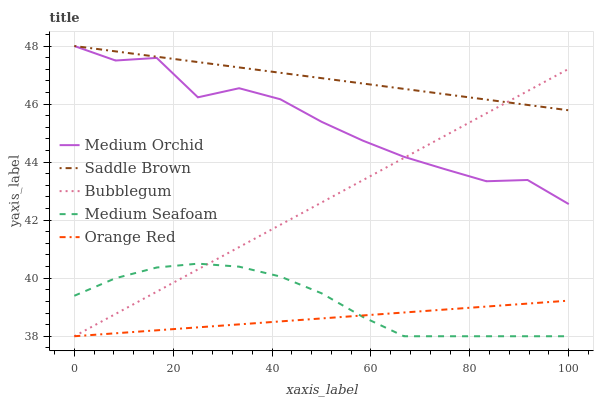Does Orange Red have the minimum area under the curve?
Answer yes or no. Yes. Does Medium Orchid have the minimum area under the curve?
Answer yes or no. No. Does Medium Orchid have the maximum area under the curve?
Answer yes or no. No. Is Saddle Brown the smoothest?
Answer yes or no. Yes. Is Medium Orchid the roughest?
Answer yes or no. Yes. Is Medium Orchid the smoothest?
Answer yes or no. No. Is Saddle Brown the roughest?
Answer yes or no. No. Does Medium Orchid have the lowest value?
Answer yes or no. No. Does Bubblegum have the highest value?
Answer yes or no. No. Is Medium Seafoam less than Medium Orchid?
Answer yes or no. Yes. Is Saddle Brown greater than Medium Seafoam?
Answer yes or no. Yes. Does Medium Seafoam intersect Medium Orchid?
Answer yes or no. No. 